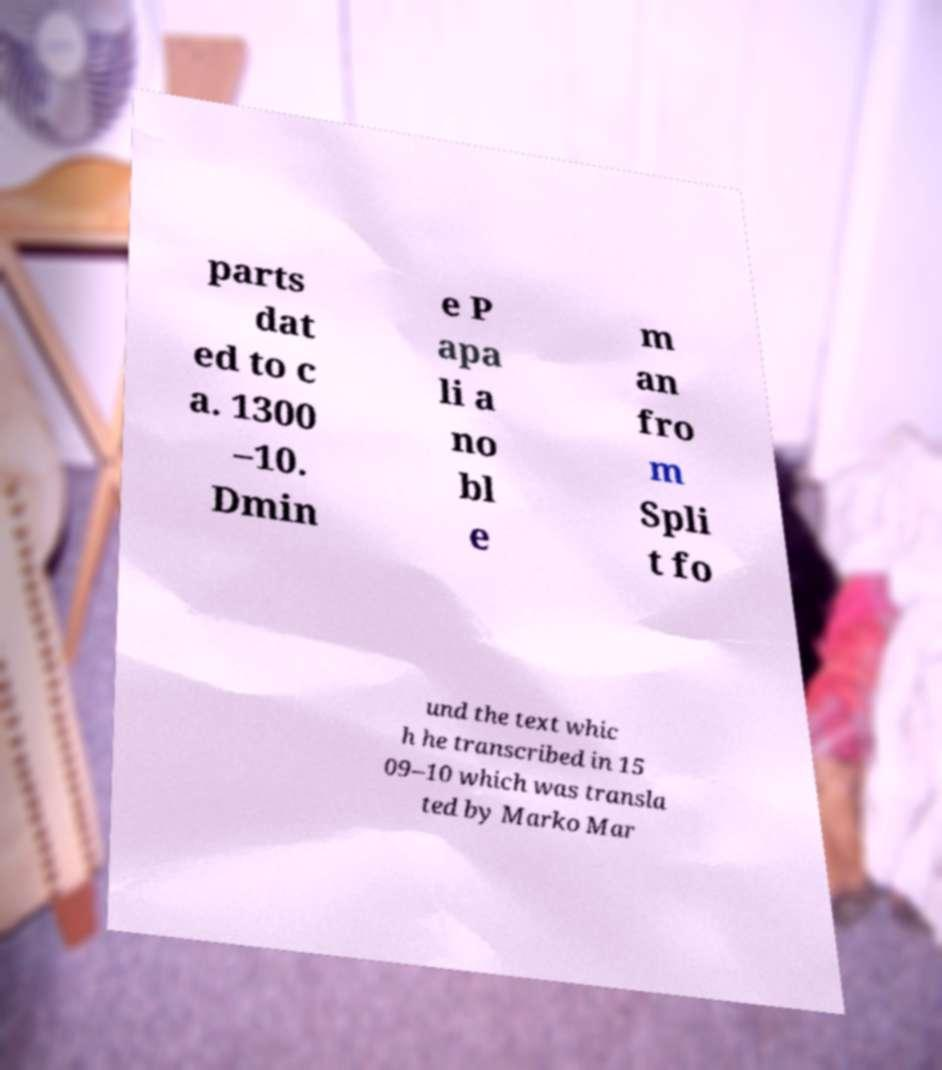Please identify and transcribe the text found in this image. parts dat ed to c a. 1300 –10. Dmin e P apa li a no bl e m an fro m Spli t fo und the text whic h he transcribed in 15 09–10 which was transla ted by Marko Mar 